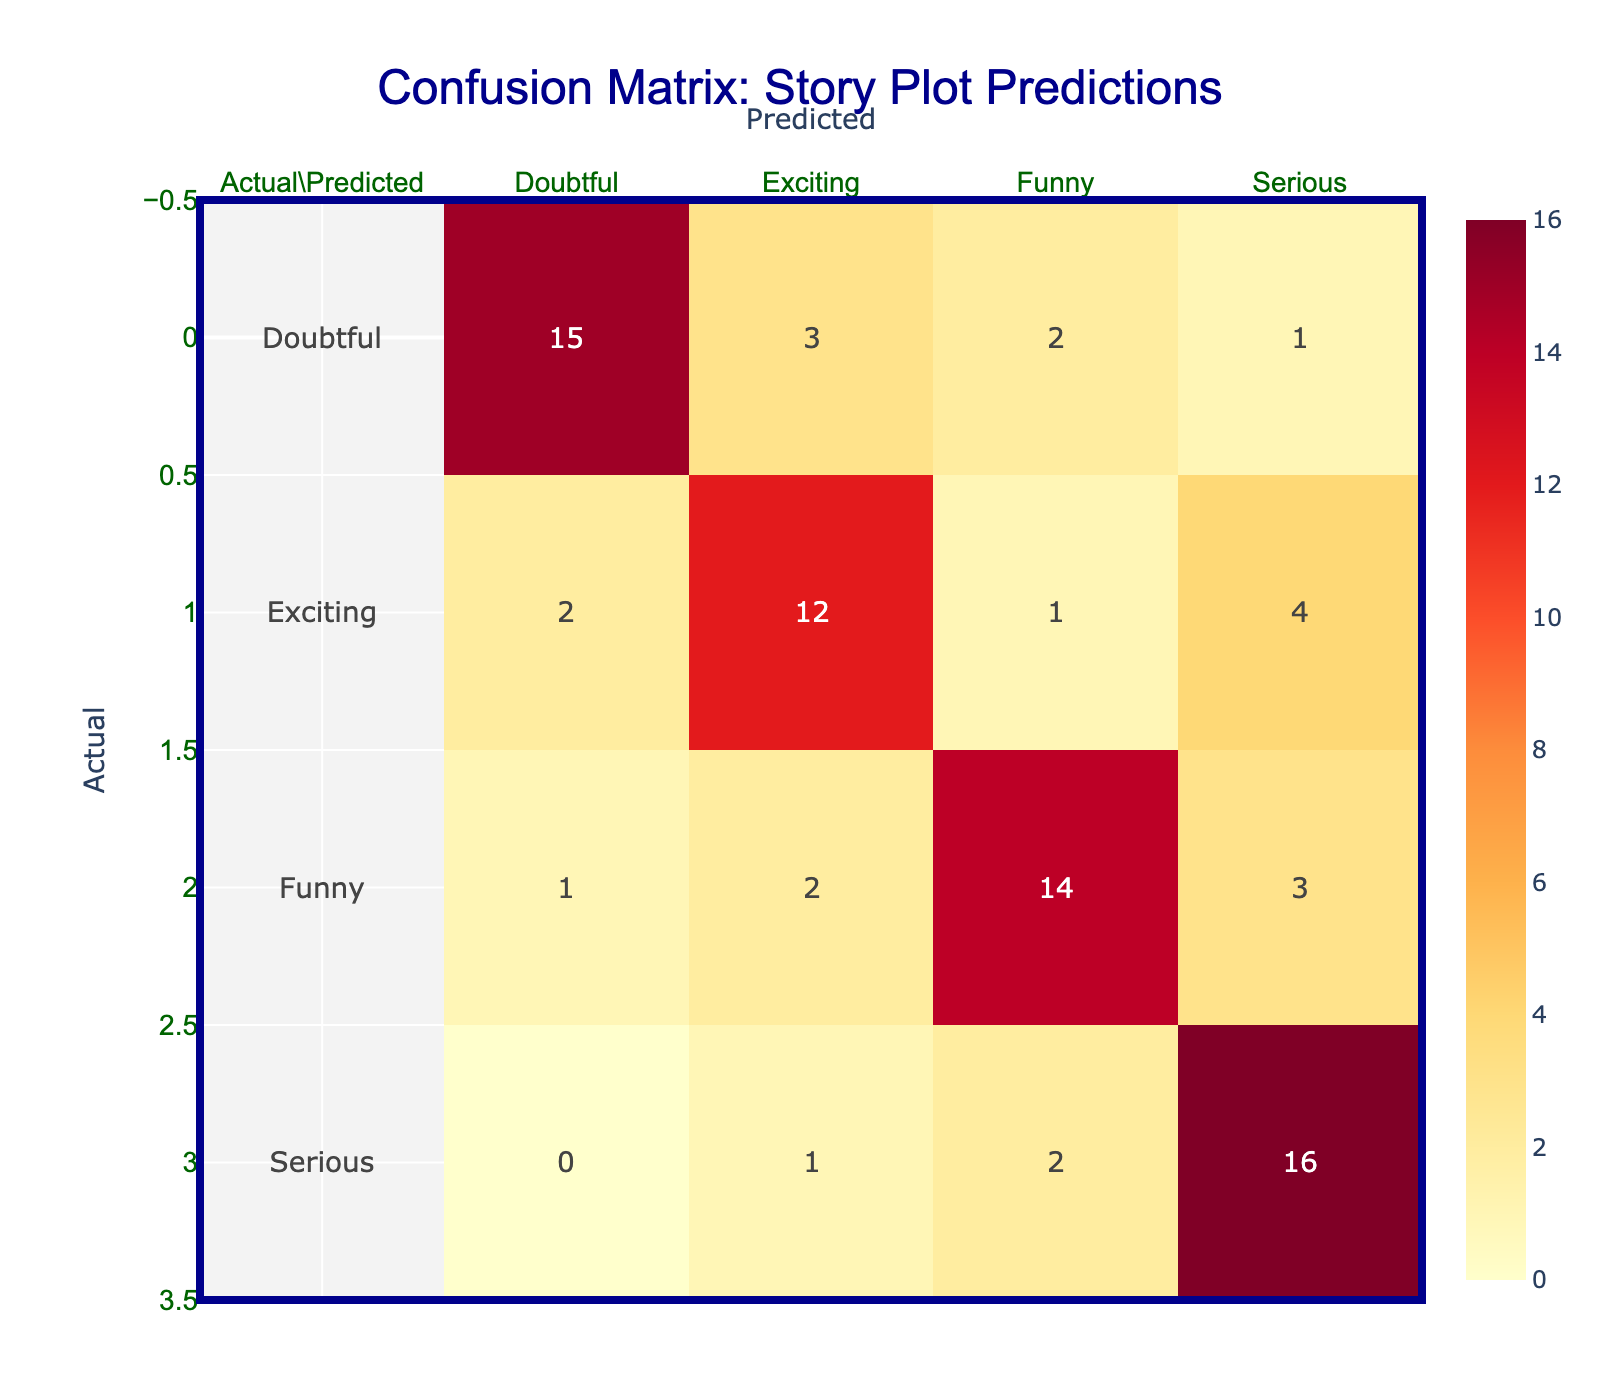What is the number of times 'Doubtful' was predicted as 'Funny'? Looking at the 'Doubtful' row and 'Funny' column in the table, we see that the value is 2. This means that 'Doubtful' was predicted as 'Funny' twice.
Answer: 2 Which category received the highest number of correct predictions? To determine the category with the highest correct predictions, we look at the diagonal of the table. The values are: Doubtful (15), Exciting (12), Funny (14), Serious (16). Since 16 is the highest, 'Serious' received the highest number of correct predictions.
Answer: Serious What is the total number of predictions made in the 'Exciting' category? To find the total predictions made in the 'Exciting' category, we sum all the values in the 'Exciting' column: 2 (Doubtful) + 12 (Exciting) + 2 (Funny) + 1 (Serious) = 17.
Answer: 17 Is 'Funny' a more frequently predicted category than 'Doubtful'? Comparing the total predictions from the 'Funny' and 'Doubtful' rows, for 'Funny', we have 1 (Doubtful) + 2 (Exciting) + 14 (Funny) + 2 (Serious) = 19. For 'Doubtful': 15 + 3 + 2 + 1 = 21. Since 19 < 21, 'Funny' is not more frequently predicted than 'Doubtful'.
Answer: No What is the percentage of 'Serious' predictions that were correct? The correct predictions for 'Serious' are found in the diagonal (16). The total predictions for 'Serious' are: 0 (Doubtful) + 1 (Exciting) + 2 (Funny) + 16 (Serious) = 19. The percentage is therefore (16/19) * 100, which approximately equals 84.21%.
Answer: 84.21% What is the difference in the number of 'Exciting' predictions compared to 'Serious' predictions? First, we find the total predictions for 'Exciting': 17 (as calculated previously). Then for 'Serious', we sum: 1 (Doubtful) + 4 (Exciting) + 3 (Funny) + 16 (Serious) = 24. The difference is 24 (Serious) - 17 (Exciting) = 7.
Answer: 7 How many times was 'Funny' predicted as 'Doubtful'? Referring to the 'Funny' row and 'Doubtful' column, the table shows a value of 1. This indicates that 'Funny' was predicted as 'Doubtful' once.
Answer: 1 Were there more 'Doubtful' predictions than 'Exciting' predictions? Total predictions for 'Doubtful' are 15 + 3 + 2 + 1 = 21. Total predictions for 'Exciting' are 17 (from previous calculations). Since 21 > 17, there were more 'Doubtful' predictions than 'Exciting' predictions.
Answer: Yes 